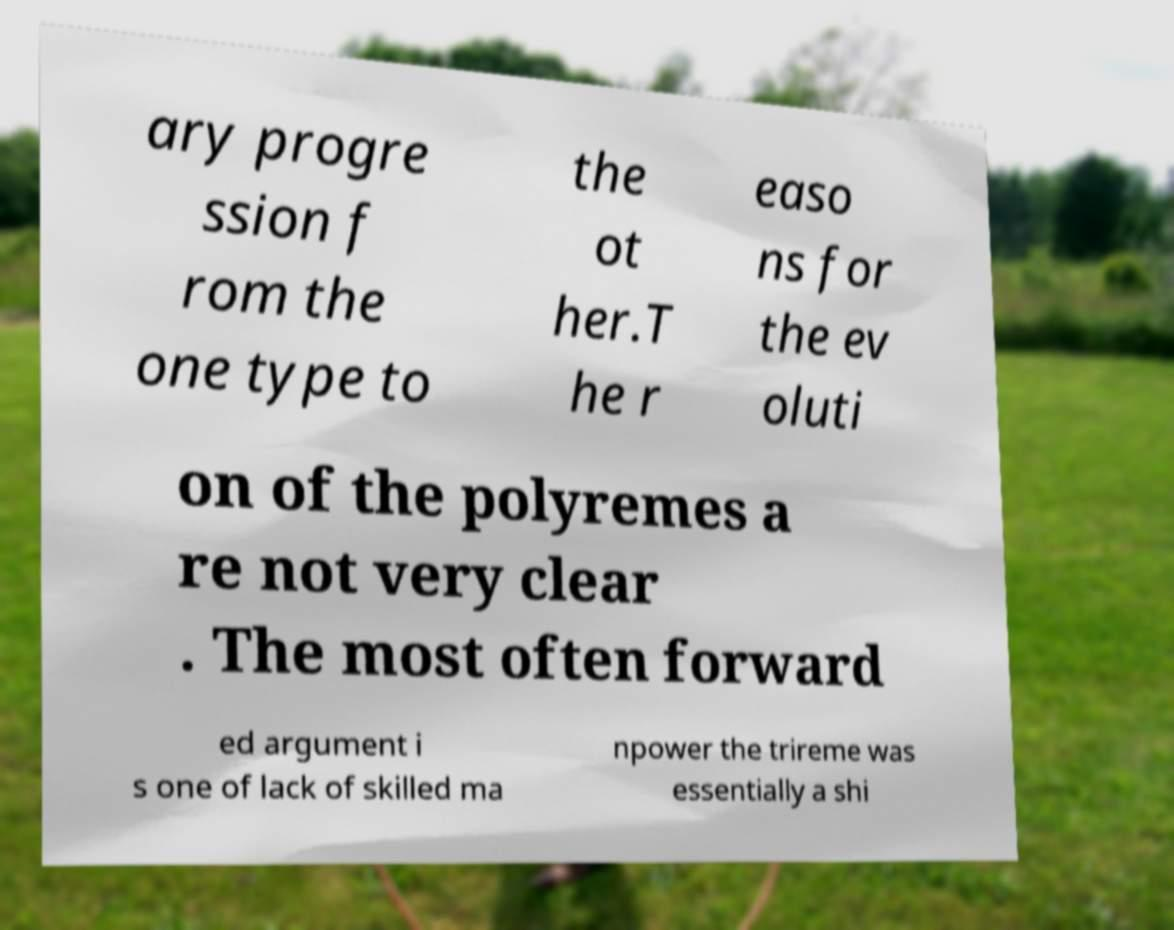For documentation purposes, I need the text within this image transcribed. Could you provide that? ary progre ssion f rom the one type to the ot her.T he r easo ns for the ev oluti on of the polyremes a re not very clear . The most often forward ed argument i s one of lack of skilled ma npower the trireme was essentially a shi 